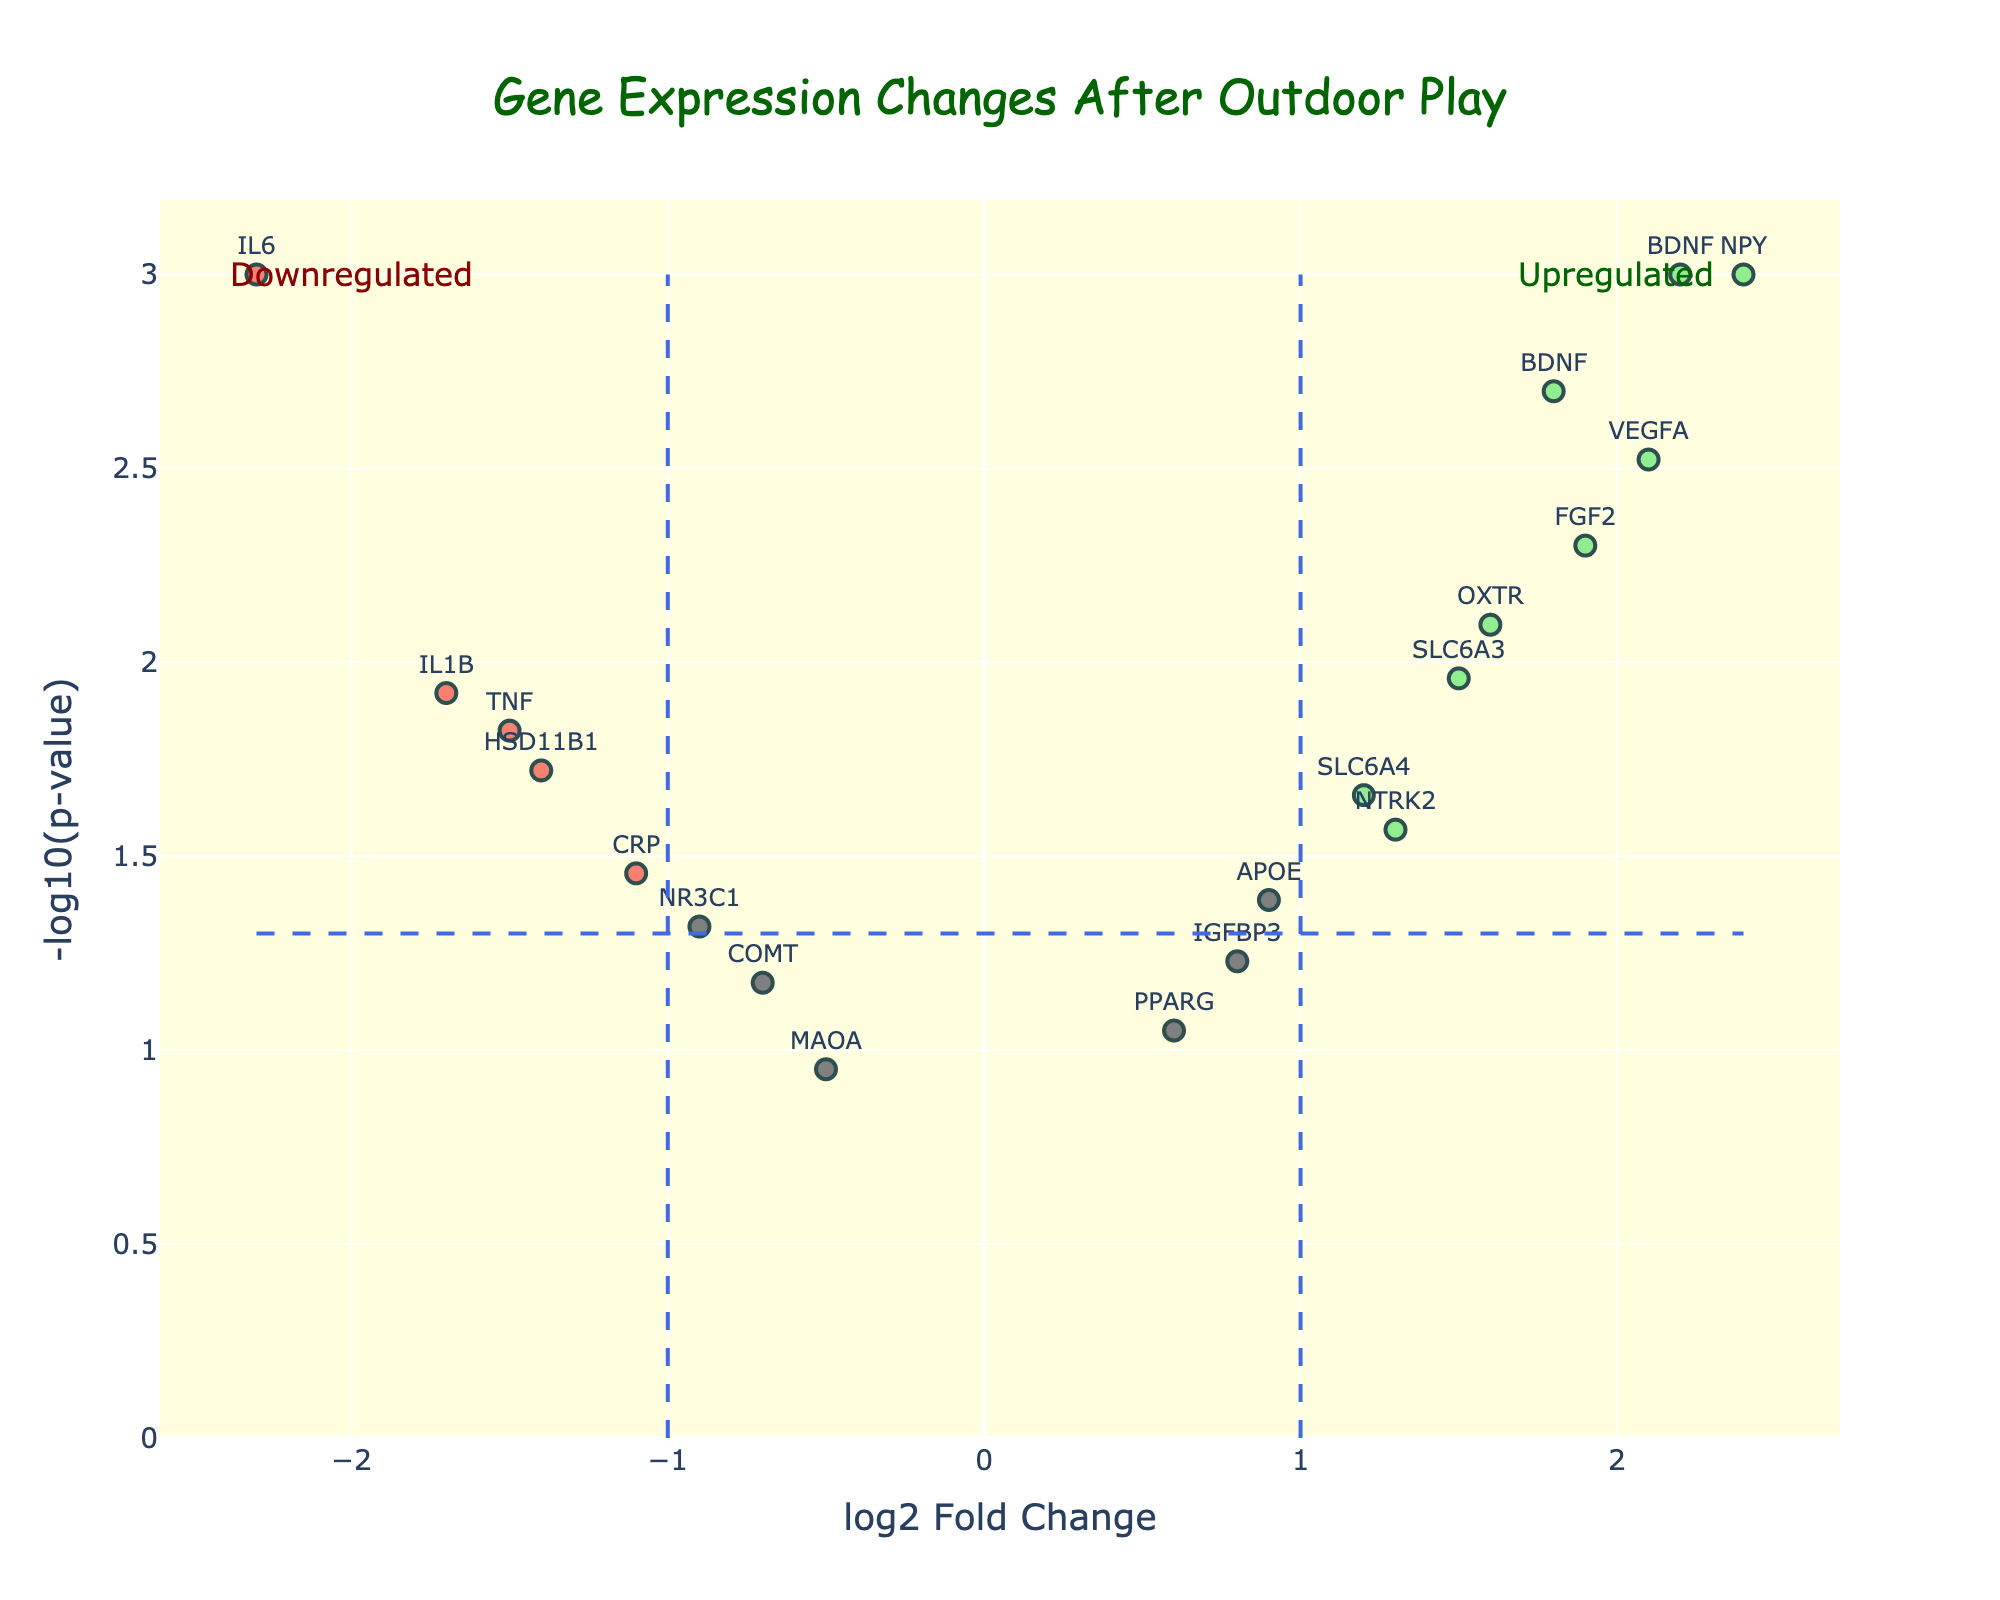What is the title of the plot? The title is located at the top of the plot and reads "Gene Expression Changes After Outdoor Play".
Answer: Gene Expression Changes After Outdoor Play Which axis represents the log2 fold change? The x-axis at the bottom of the plot represents "log2 Fold Change".
Answer: x-axis What color represents upregulated genes? Genes that are upregulated are shown in light green color.
Answer: light green How many genes are significantly upregulated? To find significantly upregulated genes, we need to look for light green points that are beyond the threshold lines at log2FoldChange > 1 and p-value < 0.05. There are 6: BDNF, VEGFA, OXTR, NPY, BDNF, and FGF2.
Answer: 6 Which gene has the highest log2 fold change and what is its value? The gene with the highest log2 fold change is identified by looking at the point farthest to the right. NPY has the highest log2 fold change of 2.4.
Answer: NPY, 2.4 Are there any genes with a log2 fold change less than -2 and a p-value less than 0.05? Yes, these genes would be shown in salmon color to the far left beyond both threshold lines. IL6 is the gene satisfying these conditions with log2FoldChange of -2.3 and p-value of 0.001.
Answer: Yes, IL6 What is the log2 fold change and p-value for the gene IL1B? The gene IL1B is marked on the plot and has a log2 fold change of -1.7 and p-value of 0.012.
Answer: -1.7, 0.012 Compare IL1B and CRP in terms of their log2 fold changes; which one is more downregulated? IL1B has a log2 fold change of -1.7, and CRP has a log2 fold change of -1.1. Since -1.7 is smaller than -1.1, IL1B is more downregulated compared to CRP.
Answer: IL1B Which gene is more significantly upregulated, BDNF or SLC6A3, and on what basis? To compare, note that BDNF has a higher log2 fold change of 2.2 compared to SLC6A3’s 1.5, and both have p-values below 0.05, indicating significance. Therefore, BDNF is more significantly upregulated.
Answer: BDNF What does the color gray signify on this plot? The gray color indicates genes that are neither significantly upregulated nor significantly downregulated because they do not meet the p-value threshold or fold change criteria.
Answer: Not significant 